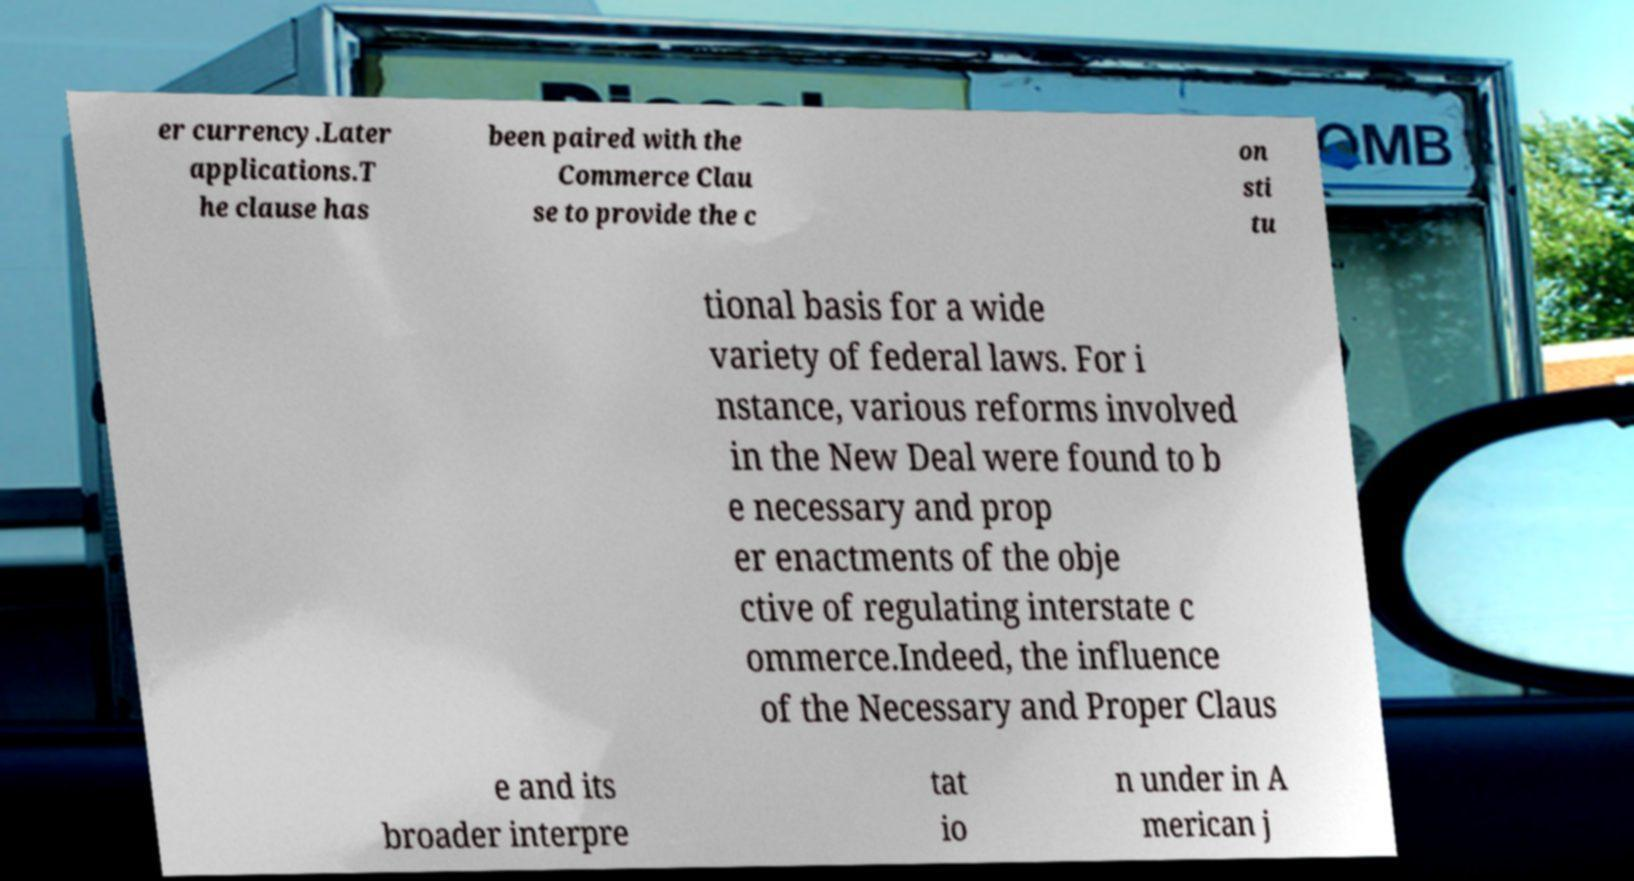I need the written content from this picture converted into text. Can you do that? er currency.Later applications.T he clause has been paired with the Commerce Clau se to provide the c on sti tu tional basis for a wide variety of federal laws. For i nstance, various reforms involved in the New Deal were found to b e necessary and prop er enactments of the obje ctive of regulating interstate c ommerce.Indeed, the influence of the Necessary and Proper Claus e and its broader interpre tat io n under in A merican j 